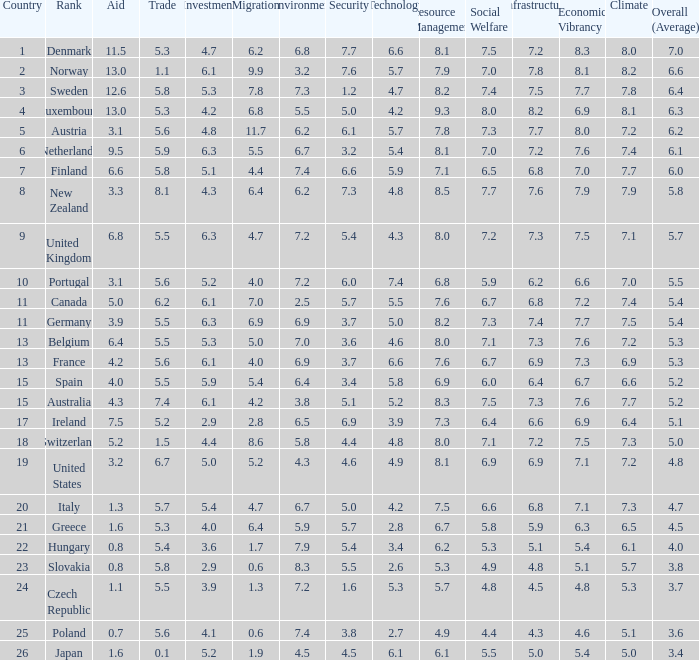How many times is denmark ranked in technology? 1.0. 